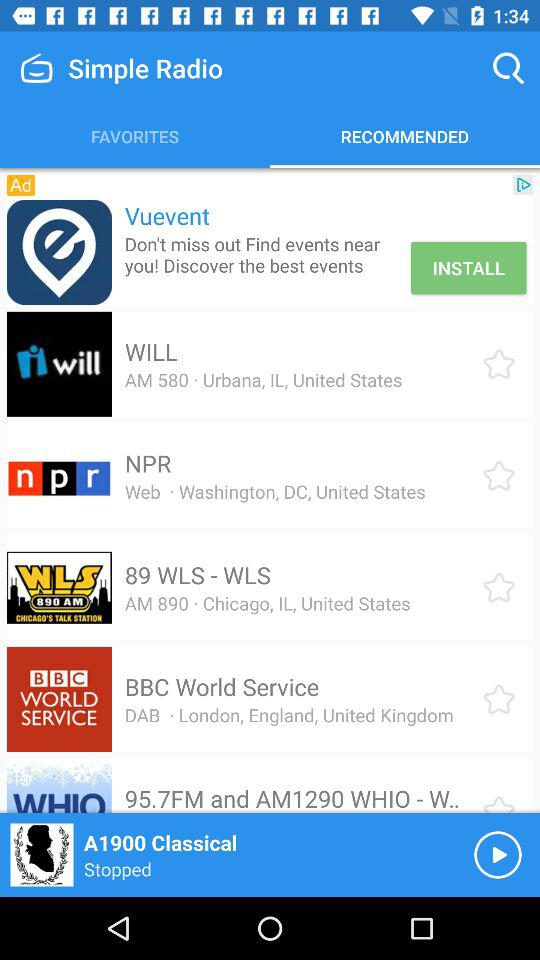What is the name of the application? The name of the application is "Simple Radio". 